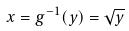Convert formula to latex. <formula><loc_0><loc_0><loc_500><loc_500>x = g ^ { - 1 } ( y ) = \sqrt { y }</formula> 